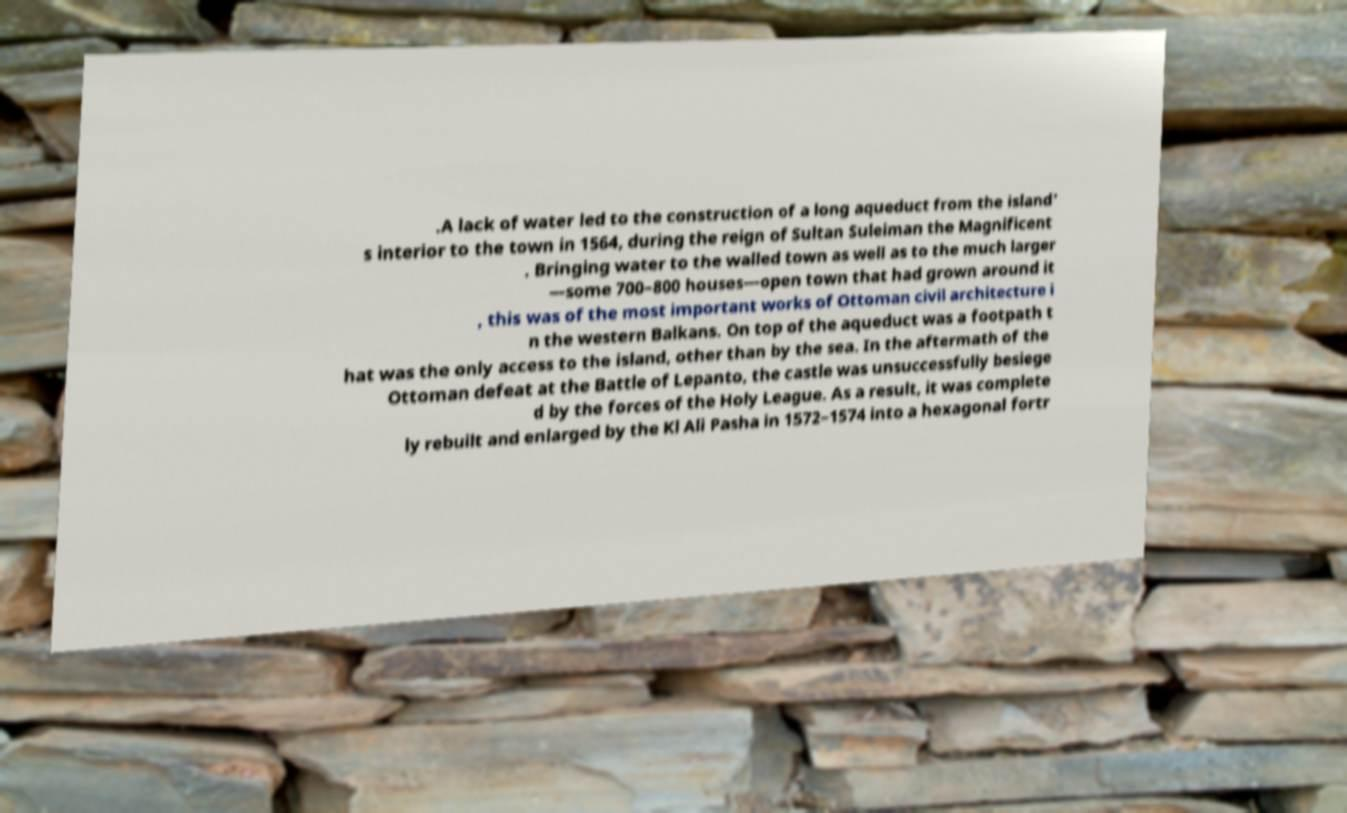There's text embedded in this image that I need extracted. Can you transcribe it verbatim? .A lack of water led to the construction of a long aqueduct from the island' s interior to the town in 1564, during the reign of Sultan Suleiman the Magnificent . Bringing water to the walled town as well as to the much larger —some 700–800 houses—open town that had grown around it , this was of the most important works of Ottoman civil architecture i n the western Balkans. On top of the aqueduct was a footpath t hat was the only access to the island, other than by the sea. In the aftermath of the Ottoman defeat at the Battle of Lepanto, the castle was unsuccessfully besiege d by the forces of the Holy League. As a result, it was complete ly rebuilt and enlarged by the Kl Ali Pasha in 1572–1574 into a hexagonal fortr 